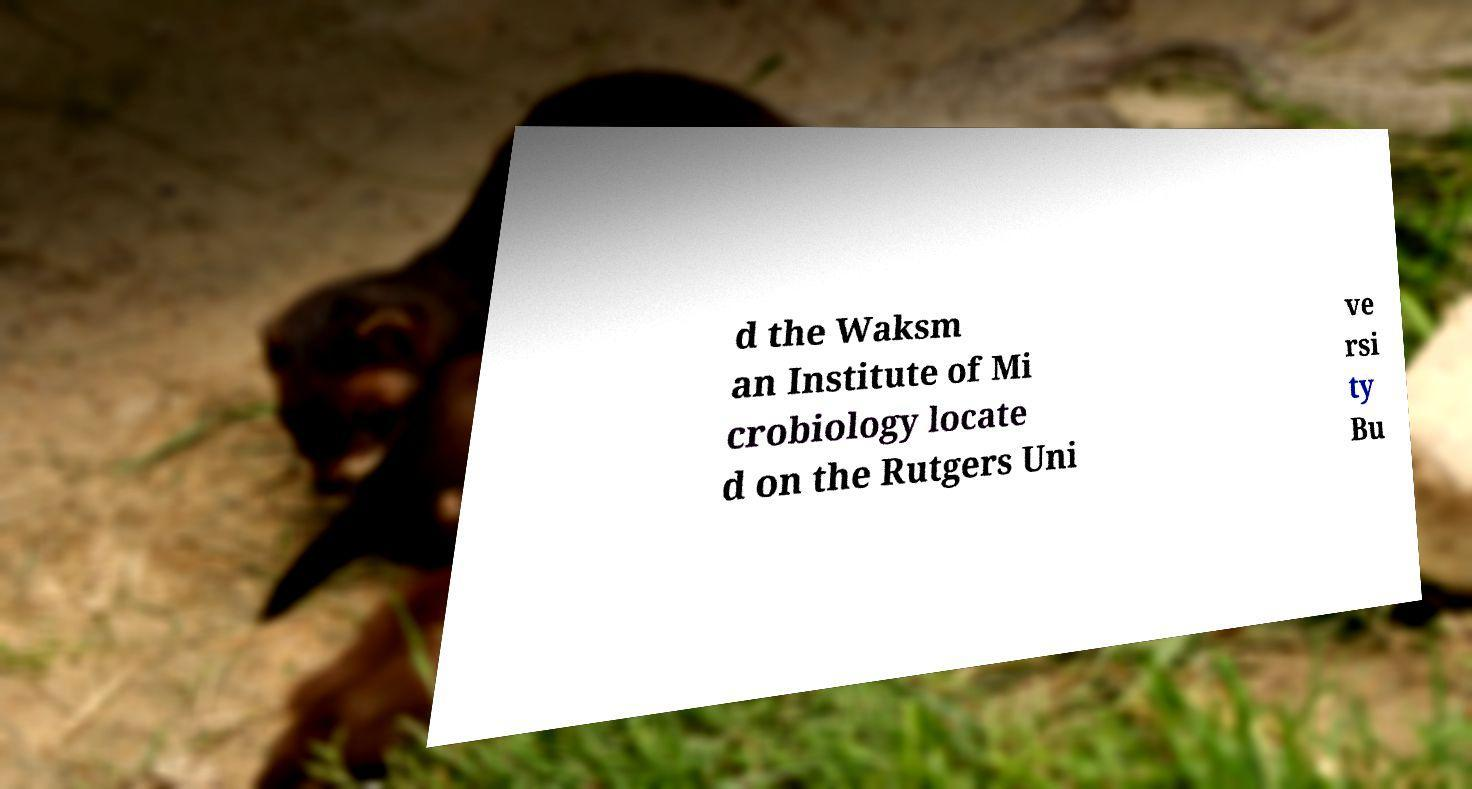Can you accurately transcribe the text from the provided image for me? d the Waksm an Institute of Mi crobiology locate d on the Rutgers Uni ve rsi ty Bu 